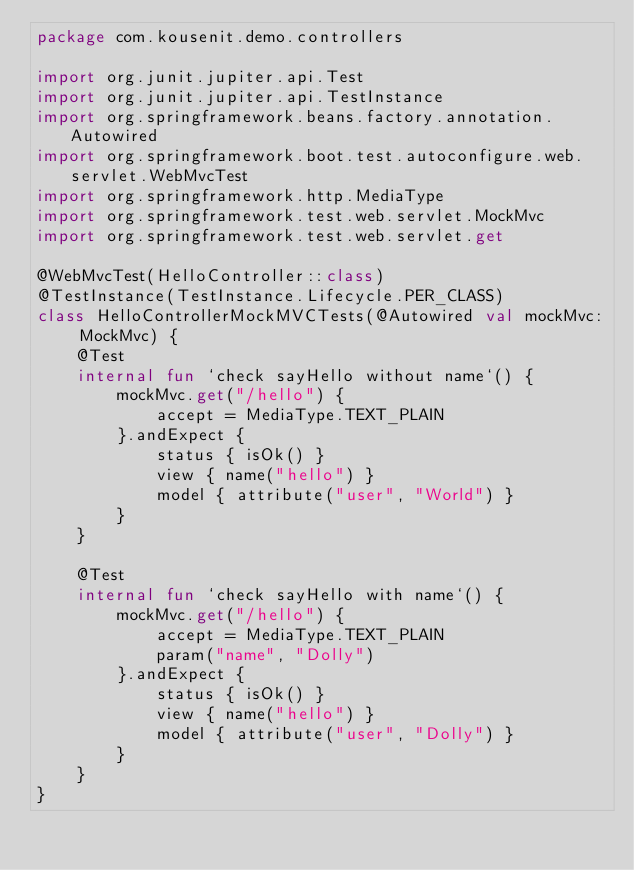Convert code to text. <code><loc_0><loc_0><loc_500><loc_500><_Kotlin_>package com.kousenit.demo.controllers

import org.junit.jupiter.api.Test
import org.junit.jupiter.api.TestInstance
import org.springframework.beans.factory.annotation.Autowired
import org.springframework.boot.test.autoconfigure.web.servlet.WebMvcTest
import org.springframework.http.MediaType
import org.springframework.test.web.servlet.MockMvc
import org.springframework.test.web.servlet.get

@WebMvcTest(HelloController::class)
@TestInstance(TestInstance.Lifecycle.PER_CLASS)
class HelloControllerMockMVCTests(@Autowired val mockMvc: MockMvc) {
    @Test
    internal fun `check sayHello without name`() {
        mockMvc.get("/hello") {
            accept = MediaType.TEXT_PLAIN
        }.andExpect {
            status { isOk() }
            view { name("hello") }
            model { attribute("user", "World") }
        }
    }

    @Test
    internal fun `check sayHello with name`() {
        mockMvc.get("/hello") {
            accept = MediaType.TEXT_PLAIN
            param("name", "Dolly")
        }.andExpect {
            status { isOk() }
            view { name("hello") }
            model { attribute("user", "Dolly") }
        }
    }
}</code> 